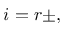Convert formula to latex. <formula><loc_0><loc_0><loc_500><loc_500>i = r \pm ,</formula> 